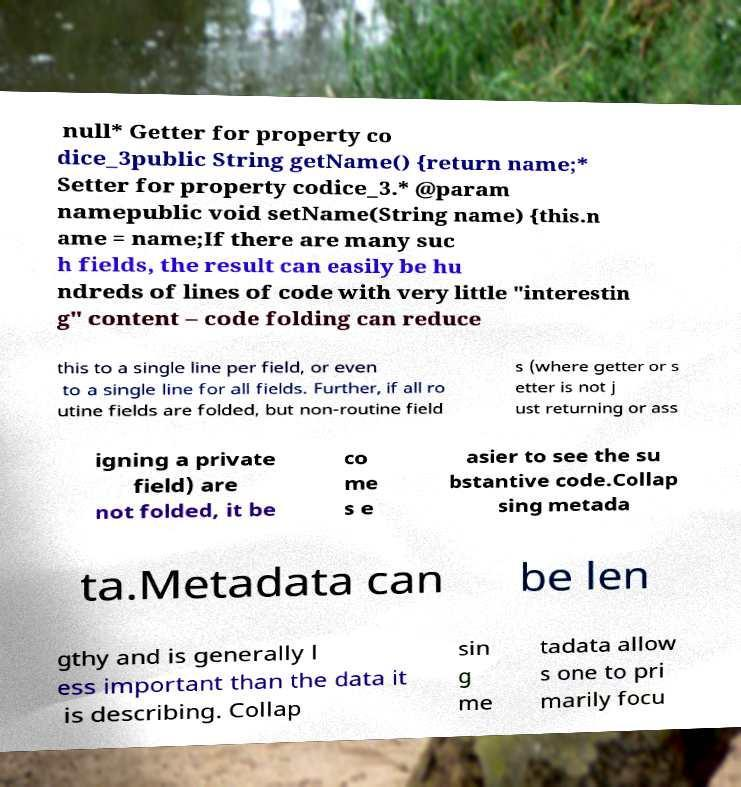Could you assist in decoding the text presented in this image and type it out clearly? null* Getter for property co dice_3public String getName() {return name;* Setter for property codice_3.* @param namepublic void setName(String name) {this.n ame = name;If there are many suc h fields, the result can easily be hu ndreds of lines of code with very little "interestin g" content – code folding can reduce this to a single line per field, or even to a single line for all fields. Further, if all ro utine fields are folded, but non-routine field s (where getter or s etter is not j ust returning or ass igning a private field) are not folded, it be co me s e asier to see the su bstantive code.Collap sing metada ta.Metadata can be len gthy and is generally l ess important than the data it is describing. Collap sin g me tadata allow s one to pri marily focu 